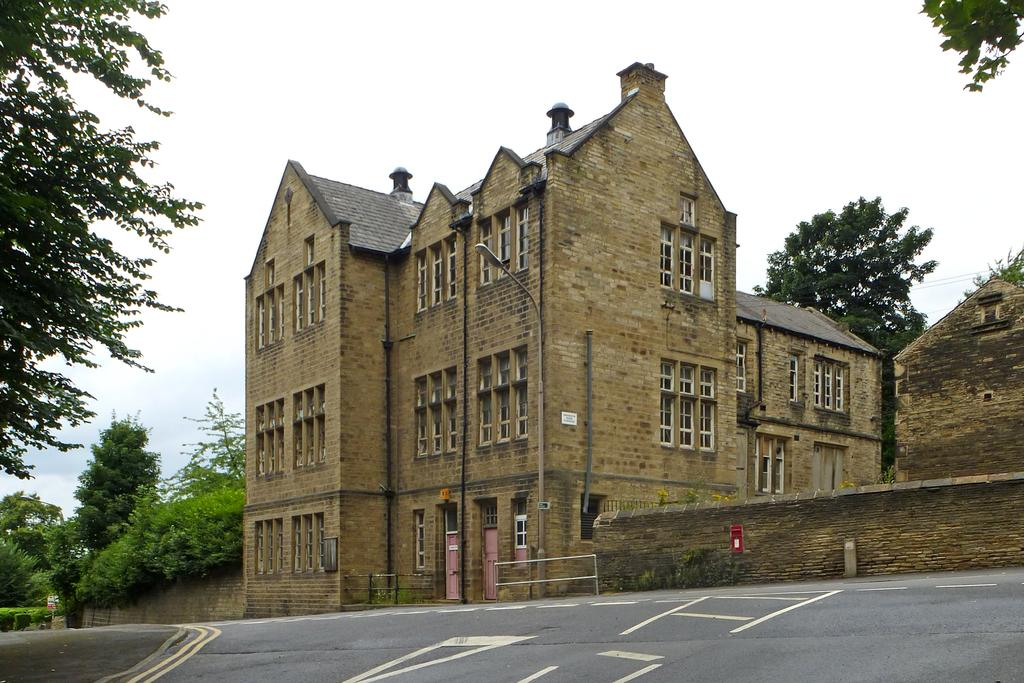What is the main feature of the image? There is a road in the image. What can be seen on the right side of the image? There is a building on the right side of the image. What type of vegetation is on the left side of the image? There are trees on the left side of the image. What is visible on both sides of the image? There are trees on both the left and right sides of the image. What is the condition of the sky in the image? The sky is clear in the image. What type of band is performing in the image? There is no band present in the image. Whose birthday is being celebrated in the image? There is no indication of a birthday celebration in the image. 